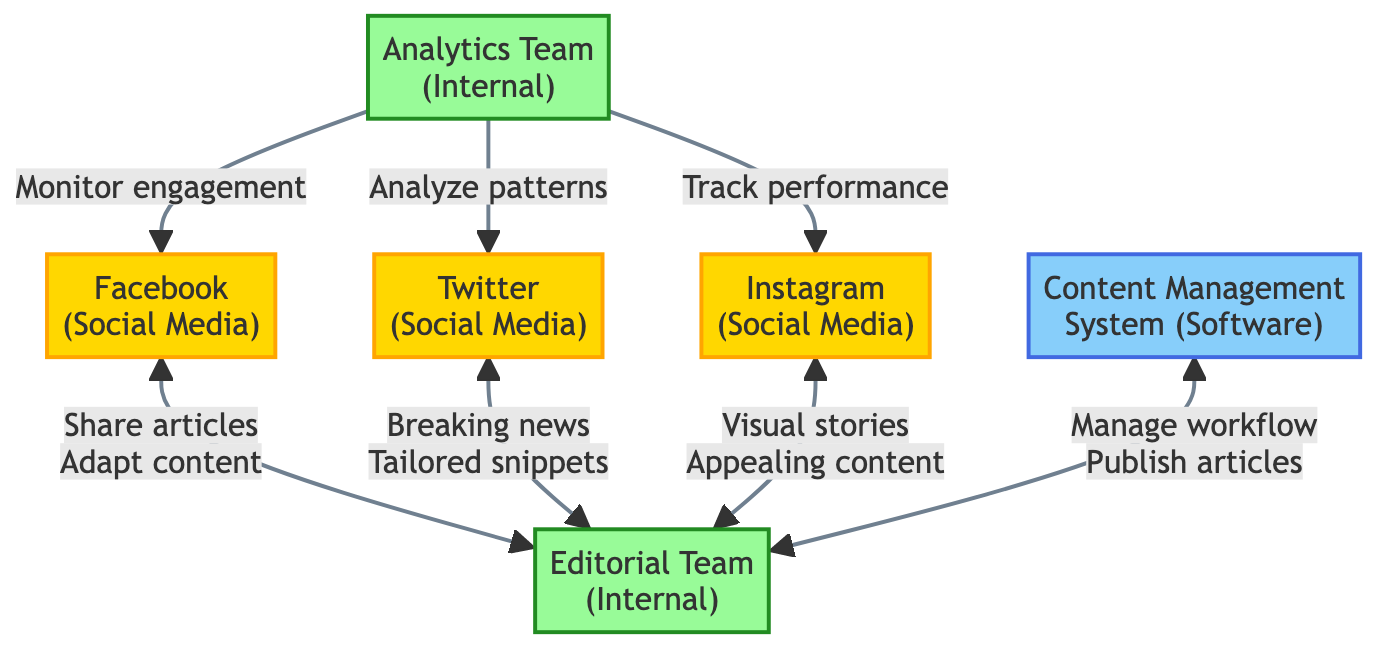What's the total number of nodes in the diagram? The diagram includes six nodes: Facebook, Twitter, Instagram, Editorial Team, Analytics Team, and Content Management System, so the total is six.
Answer: 6 What type of relationships exist between the Editorial Team and Facebook? There are two interactions between the Editorial Team and Facebook: the Editorial Team shares articles on Facebook and adapts content for Facebook.
Answer: Sharing articles, adapting content How many edges connect the nodes related to social media platforms? There are six edges connecting the Editorial Team to each social media platform (Facebook, Twitter, and Instagram), plus three edges from the Analytics Team to the social media platforms, totaling nine.
Answer: 9 Which internal team monitors user engagement metrics on Facebook? The Analytics Team is responsible for monitoring and reporting on user engagement metrics for Facebook.
Answer: Analytics Team What type of content does the Editorial Team create specifically for Instagram? The Editorial Team creates visually appealing news content tailored for Instagram, including images and short videos.
Answer: Visually appealing news content How many interactions does the Analytics Team have with the social media platforms? The Analytics Team interacts with each social media platform (Facebook, Twitter, Instagram) once, resulting in three interactions total.
Answer: 3 What is the role of the Content Management System in the diagram? The Content Management System facilitates the drafting and publishing of news articles for the Editorial Team and is necessary for managing their workflow.
Answer: Drafting and publishing articles Which social media platform is primarily known for real-time news dissemination? Twitter is characterized as the platform known for real-time news dissemination.
Answer: Twitter Which node does the Editorial Team use to manage editorial workflow? The Editorial Team utilizes the Content Management System to manage their editorial workflow and content.
Answer: Content Management System 